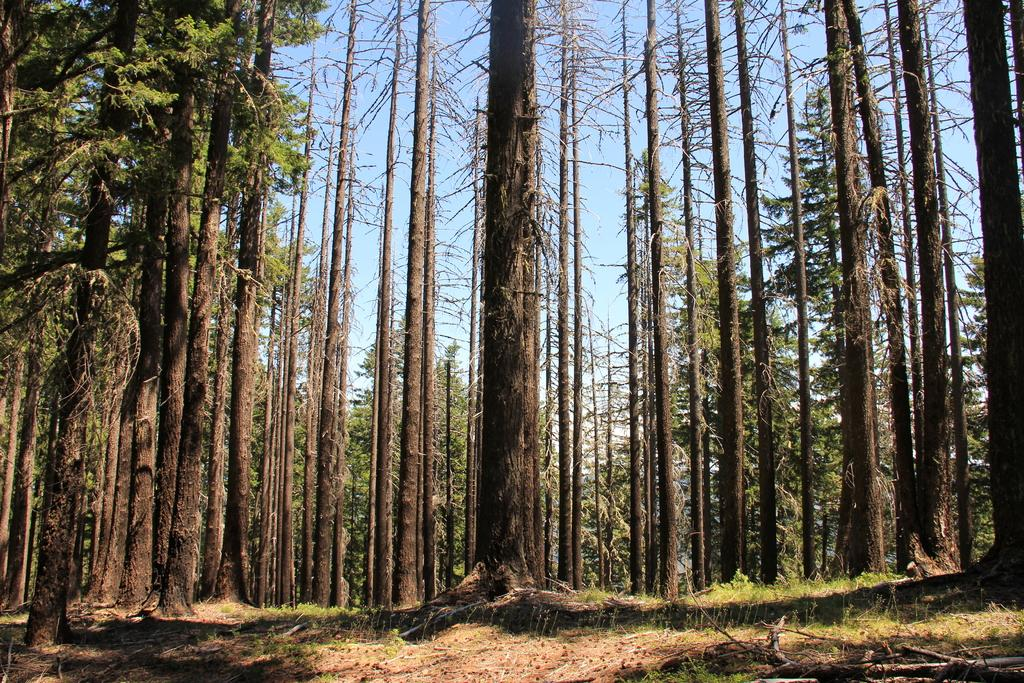What type of vegetation can be seen in the image? There are trees in the image. What is present at the bottom of the image? There is grass at the bottom of the image. What part of the natural environment is visible in the image? The sky is visible at the top of the image. Can you see the maid hanging the laundry on the trees in the image? There is no maid or laundry present in the image; it only features trees, grass, and the sky. Is there a ball rolling on the grass in the image? There is no ball present in the image; it only features trees, grass, and the sky. 